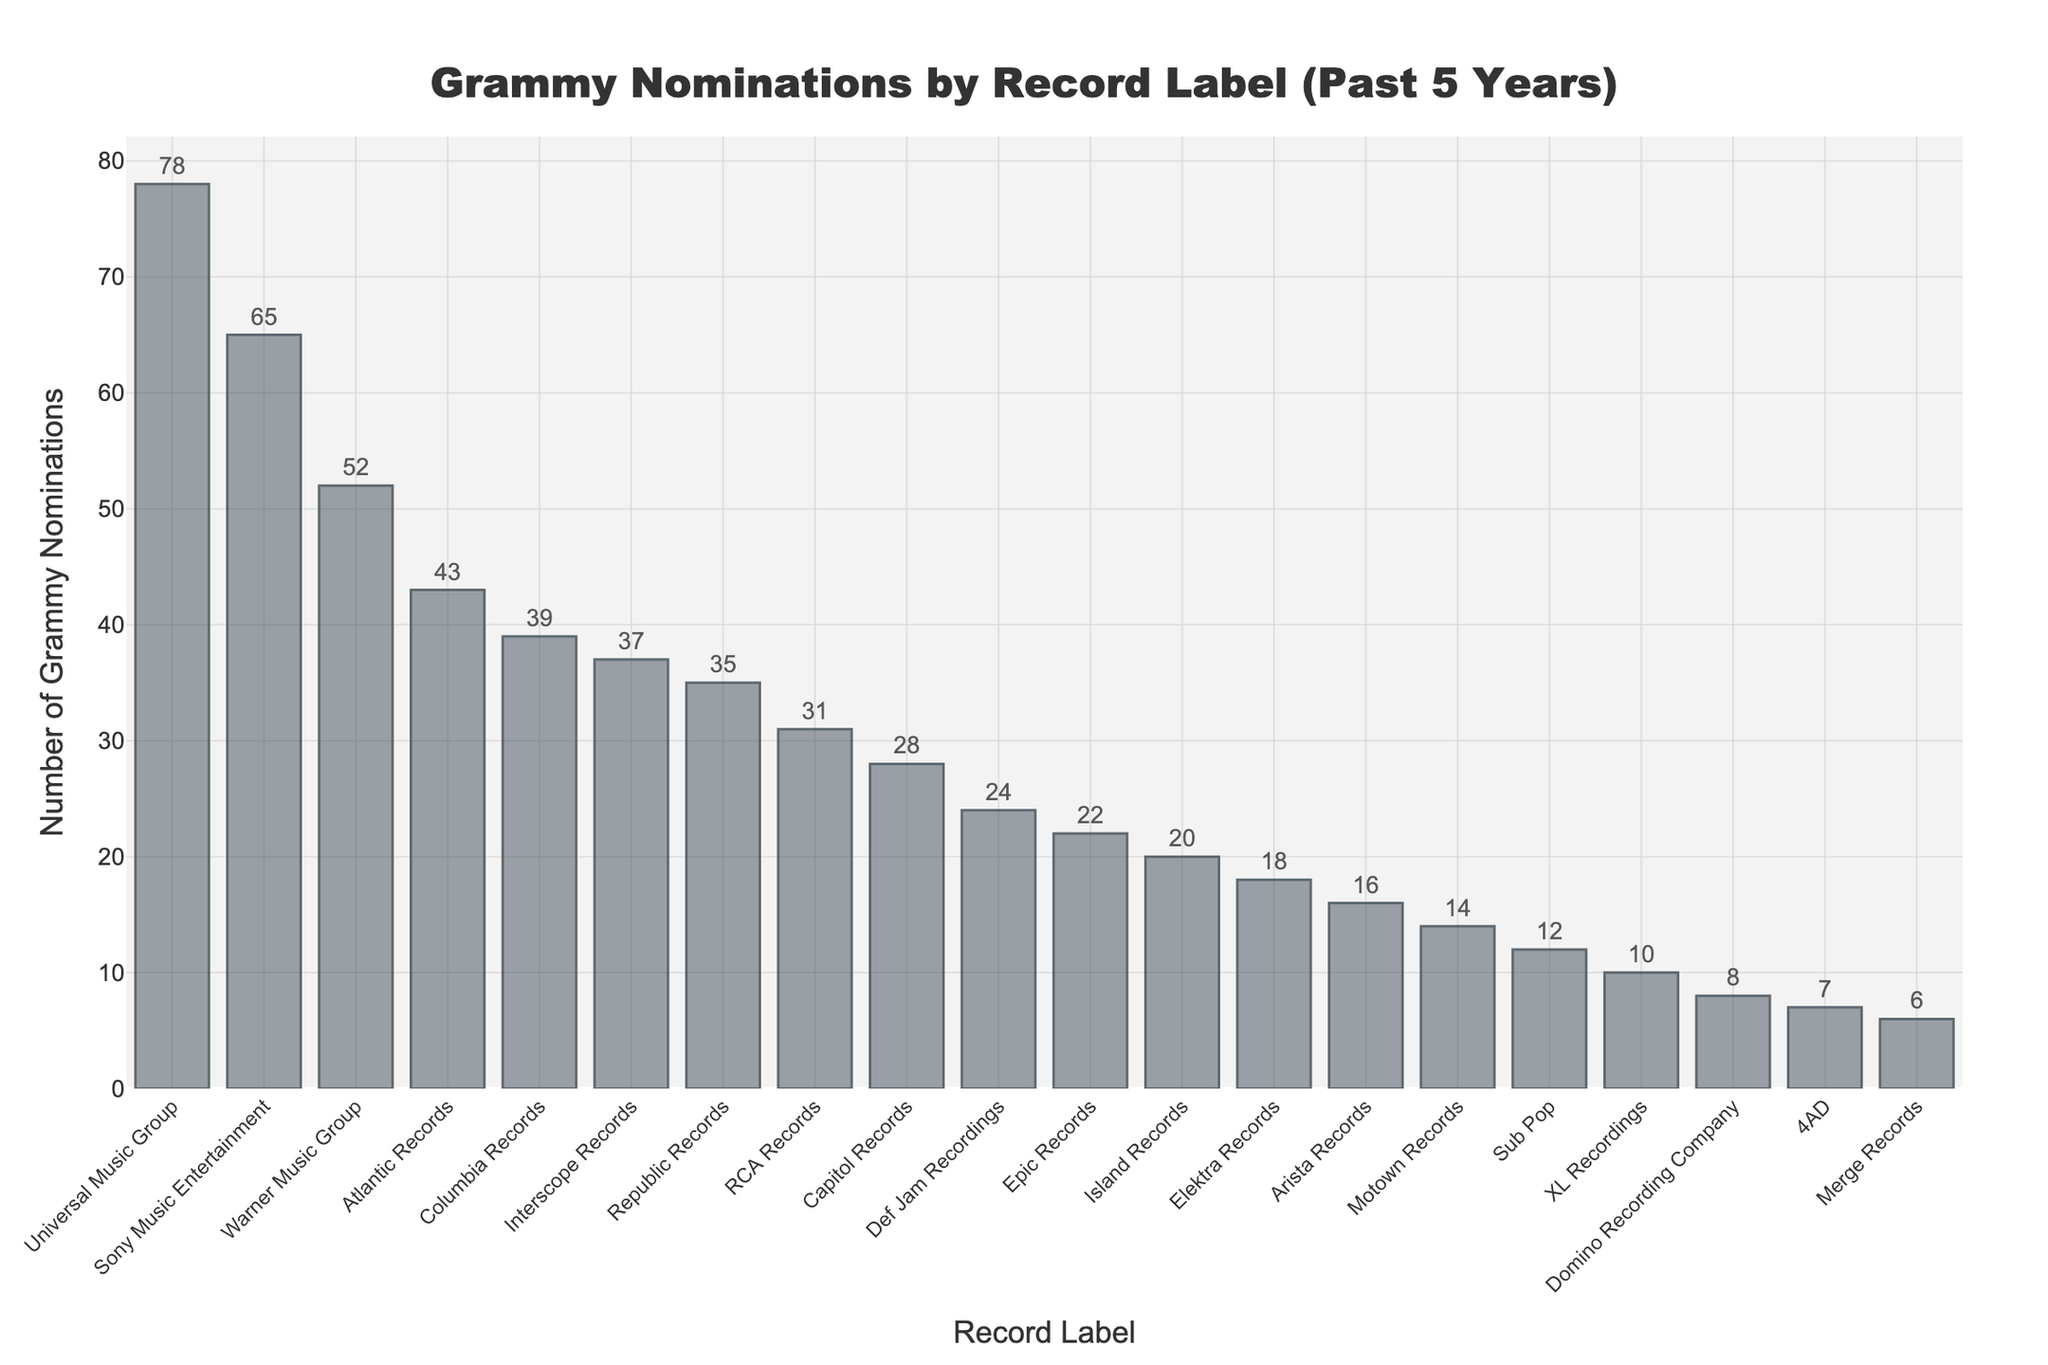Which record label received the most Grammy nominations? The tallest bar in the chart represents Universal Music Group, indicating it has the highest number of nominations, which is 78.
Answer: Universal Music Group Which record label received the least Grammy nominations? The shortest bar in the chart represents Merge Records, indicating it has the lowest number of nominations, which is 6.
Answer: Merge Records How many more nominations did Universal Music Group receive compared to Sony Music Entertainment? Universal Music Group received 78 nominations, and Sony Music Entertainment received 65 nominations. The difference is 78 - 65 = 13.
Answer: 13 What is the total number of Grammy nominations received by Atlantic Records, Columbia Records, and Interscope Records? Atlantic Records has 43 nominations, Columbia Records has 39 nominations, and Interscope Records has 37 nominations. The total is 43 + 39 + 37 = 119.
Answer: 119 Which record labels have received exactly 20 Grammy nominations? The bar corresponding to 20 nominations is for Island Records.
Answer: Island Records Rank the top three record labels by Grammy nominations. The record labels with the highest nominations are 1) Universal Music Group with 78 nominations, 2) Sony Music Entertainment with 65 nominations, and 3) Warner Music Group with 52 nominations.
Answer: Universal Music Group, Sony Music Entertainment, Warner Music Group How many more nominations did Capitol Records receive compared to Epic Records? Capitol Records received 28 nominations, and Epic Records received 22 nominations. The difference is 28 - 22 = 6.
Answer: 6 What's the median number of Grammy nominations received by the record labels? To find the median, list the nominations in ascending order: 6, 7, 8, 10, 12, 14, 16, 18, 20, 22, 24, 28, 31, 35, 37, 39, 43, 52, 65, 78. Since there are 20 labels, the median is the average of the 10th and 11th values: (22 + 24) / 2 = 23.
Answer: 23 Which record label has more Grammy nominations: Republic Records or RCA Records? Republic Records received 35 nominations, and RCA Records received 31 nominations. Republic Records has more.
Answer: Republic Records 